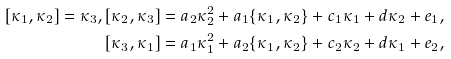<formula> <loc_0><loc_0><loc_500><loc_500>[ \kappa _ { 1 } , \kappa _ { 2 } ] = \kappa _ { 3 } , [ \kappa _ { 2 } , \kappa _ { 3 } ] = a _ { 2 } \kappa _ { 2 } ^ { 2 } + a _ { 1 } \{ \kappa _ { 1 } , \kappa _ { 2 } \} + c _ { 1 } \kappa _ { 1 } + d \kappa _ { 2 } + e _ { 1 } , \\ [ \kappa _ { 3 } , \kappa _ { 1 } ] = a _ { 1 } \kappa _ { 1 } ^ { 2 } + a _ { 2 } \{ \kappa _ { 1 } , \kappa _ { 2 } \} + c _ { 2 } \kappa _ { 2 } + d \kappa _ { 1 } + e _ { 2 } ,</formula> 